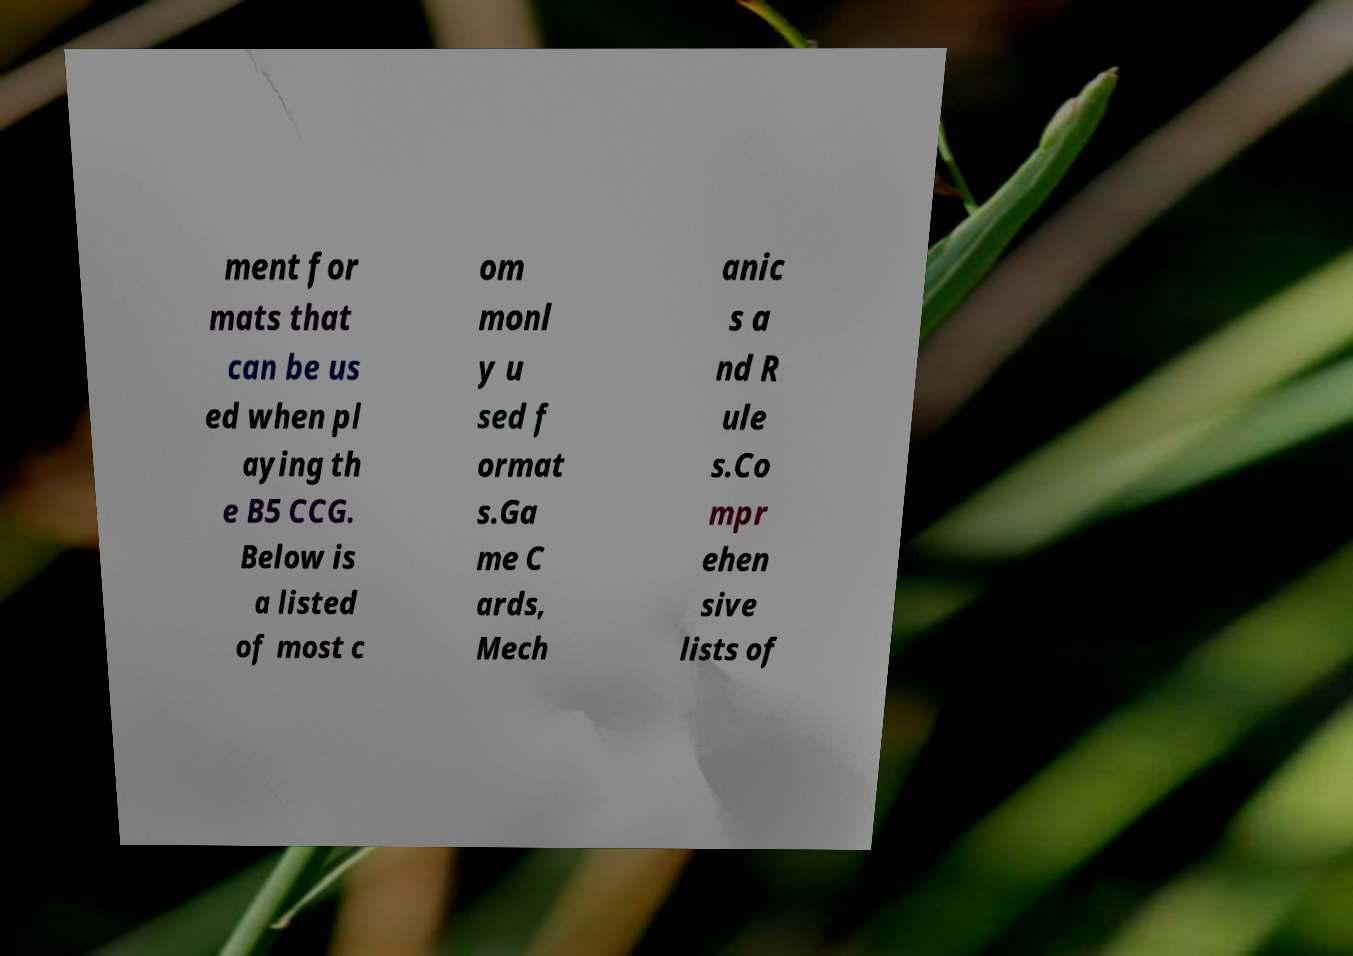There's text embedded in this image that I need extracted. Can you transcribe it verbatim? ment for mats that can be us ed when pl aying th e B5 CCG. Below is a listed of most c om monl y u sed f ormat s.Ga me C ards, Mech anic s a nd R ule s.Co mpr ehen sive lists of 